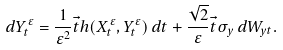Convert formula to latex. <formula><loc_0><loc_0><loc_500><loc_500>d { Y } _ { t } ^ { \varepsilon } = \frac { 1 } { \varepsilon ^ { 2 } } \vec { t } h ( { X } _ { t } ^ { \varepsilon } , { Y } _ { t } ^ { \varepsilon } ) \, d t + \frac { \sqrt { 2 } } { \varepsilon } \vec { t } \sigma _ { y } \, d { W } _ { y t } .</formula> 